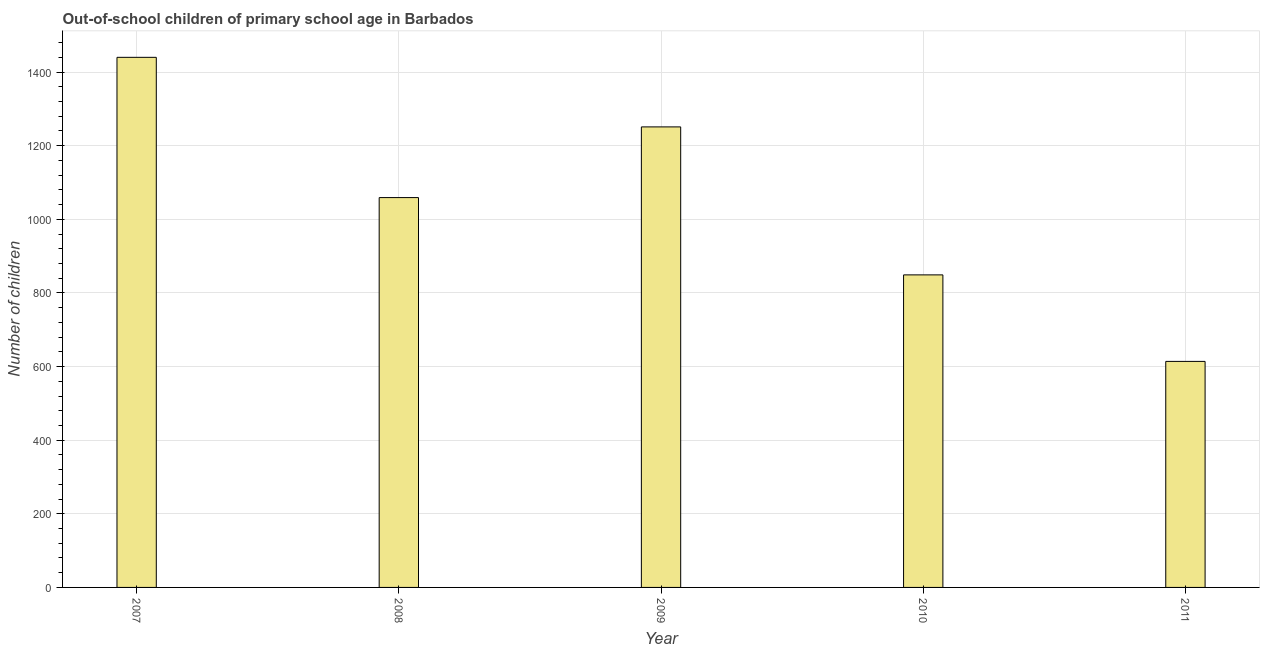Does the graph contain grids?
Make the answer very short. Yes. What is the title of the graph?
Offer a very short reply. Out-of-school children of primary school age in Barbados. What is the label or title of the Y-axis?
Offer a terse response. Number of children. What is the number of out-of-school children in 2009?
Provide a short and direct response. 1251. Across all years, what is the maximum number of out-of-school children?
Your response must be concise. 1440. Across all years, what is the minimum number of out-of-school children?
Your response must be concise. 614. In which year was the number of out-of-school children maximum?
Make the answer very short. 2007. What is the sum of the number of out-of-school children?
Your answer should be very brief. 5213. What is the difference between the number of out-of-school children in 2009 and 2010?
Your response must be concise. 402. What is the average number of out-of-school children per year?
Ensure brevity in your answer.  1042. What is the median number of out-of-school children?
Your answer should be very brief. 1059. In how many years, is the number of out-of-school children greater than 240 ?
Your answer should be very brief. 5. What is the ratio of the number of out-of-school children in 2007 to that in 2009?
Give a very brief answer. 1.15. Is the number of out-of-school children in 2007 less than that in 2009?
Provide a short and direct response. No. Is the difference between the number of out-of-school children in 2008 and 2011 greater than the difference between any two years?
Offer a terse response. No. What is the difference between the highest and the second highest number of out-of-school children?
Ensure brevity in your answer.  189. What is the difference between the highest and the lowest number of out-of-school children?
Provide a short and direct response. 826. In how many years, is the number of out-of-school children greater than the average number of out-of-school children taken over all years?
Your answer should be very brief. 3. How many bars are there?
Offer a terse response. 5. How many years are there in the graph?
Ensure brevity in your answer.  5. What is the difference between two consecutive major ticks on the Y-axis?
Your answer should be very brief. 200. Are the values on the major ticks of Y-axis written in scientific E-notation?
Provide a succinct answer. No. What is the Number of children in 2007?
Your response must be concise. 1440. What is the Number of children of 2008?
Ensure brevity in your answer.  1059. What is the Number of children in 2009?
Your answer should be compact. 1251. What is the Number of children in 2010?
Offer a very short reply. 849. What is the Number of children of 2011?
Provide a succinct answer. 614. What is the difference between the Number of children in 2007 and 2008?
Your answer should be very brief. 381. What is the difference between the Number of children in 2007 and 2009?
Keep it short and to the point. 189. What is the difference between the Number of children in 2007 and 2010?
Your response must be concise. 591. What is the difference between the Number of children in 2007 and 2011?
Your answer should be compact. 826. What is the difference between the Number of children in 2008 and 2009?
Your answer should be very brief. -192. What is the difference between the Number of children in 2008 and 2010?
Your answer should be very brief. 210. What is the difference between the Number of children in 2008 and 2011?
Your response must be concise. 445. What is the difference between the Number of children in 2009 and 2010?
Your answer should be very brief. 402. What is the difference between the Number of children in 2009 and 2011?
Your answer should be compact. 637. What is the difference between the Number of children in 2010 and 2011?
Give a very brief answer. 235. What is the ratio of the Number of children in 2007 to that in 2008?
Your response must be concise. 1.36. What is the ratio of the Number of children in 2007 to that in 2009?
Offer a very short reply. 1.15. What is the ratio of the Number of children in 2007 to that in 2010?
Make the answer very short. 1.7. What is the ratio of the Number of children in 2007 to that in 2011?
Offer a very short reply. 2.35. What is the ratio of the Number of children in 2008 to that in 2009?
Give a very brief answer. 0.85. What is the ratio of the Number of children in 2008 to that in 2010?
Your answer should be very brief. 1.25. What is the ratio of the Number of children in 2008 to that in 2011?
Give a very brief answer. 1.73. What is the ratio of the Number of children in 2009 to that in 2010?
Give a very brief answer. 1.47. What is the ratio of the Number of children in 2009 to that in 2011?
Keep it short and to the point. 2.04. What is the ratio of the Number of children in 2010 to that in 2011?
Provide a succinct answer. 1.38. 